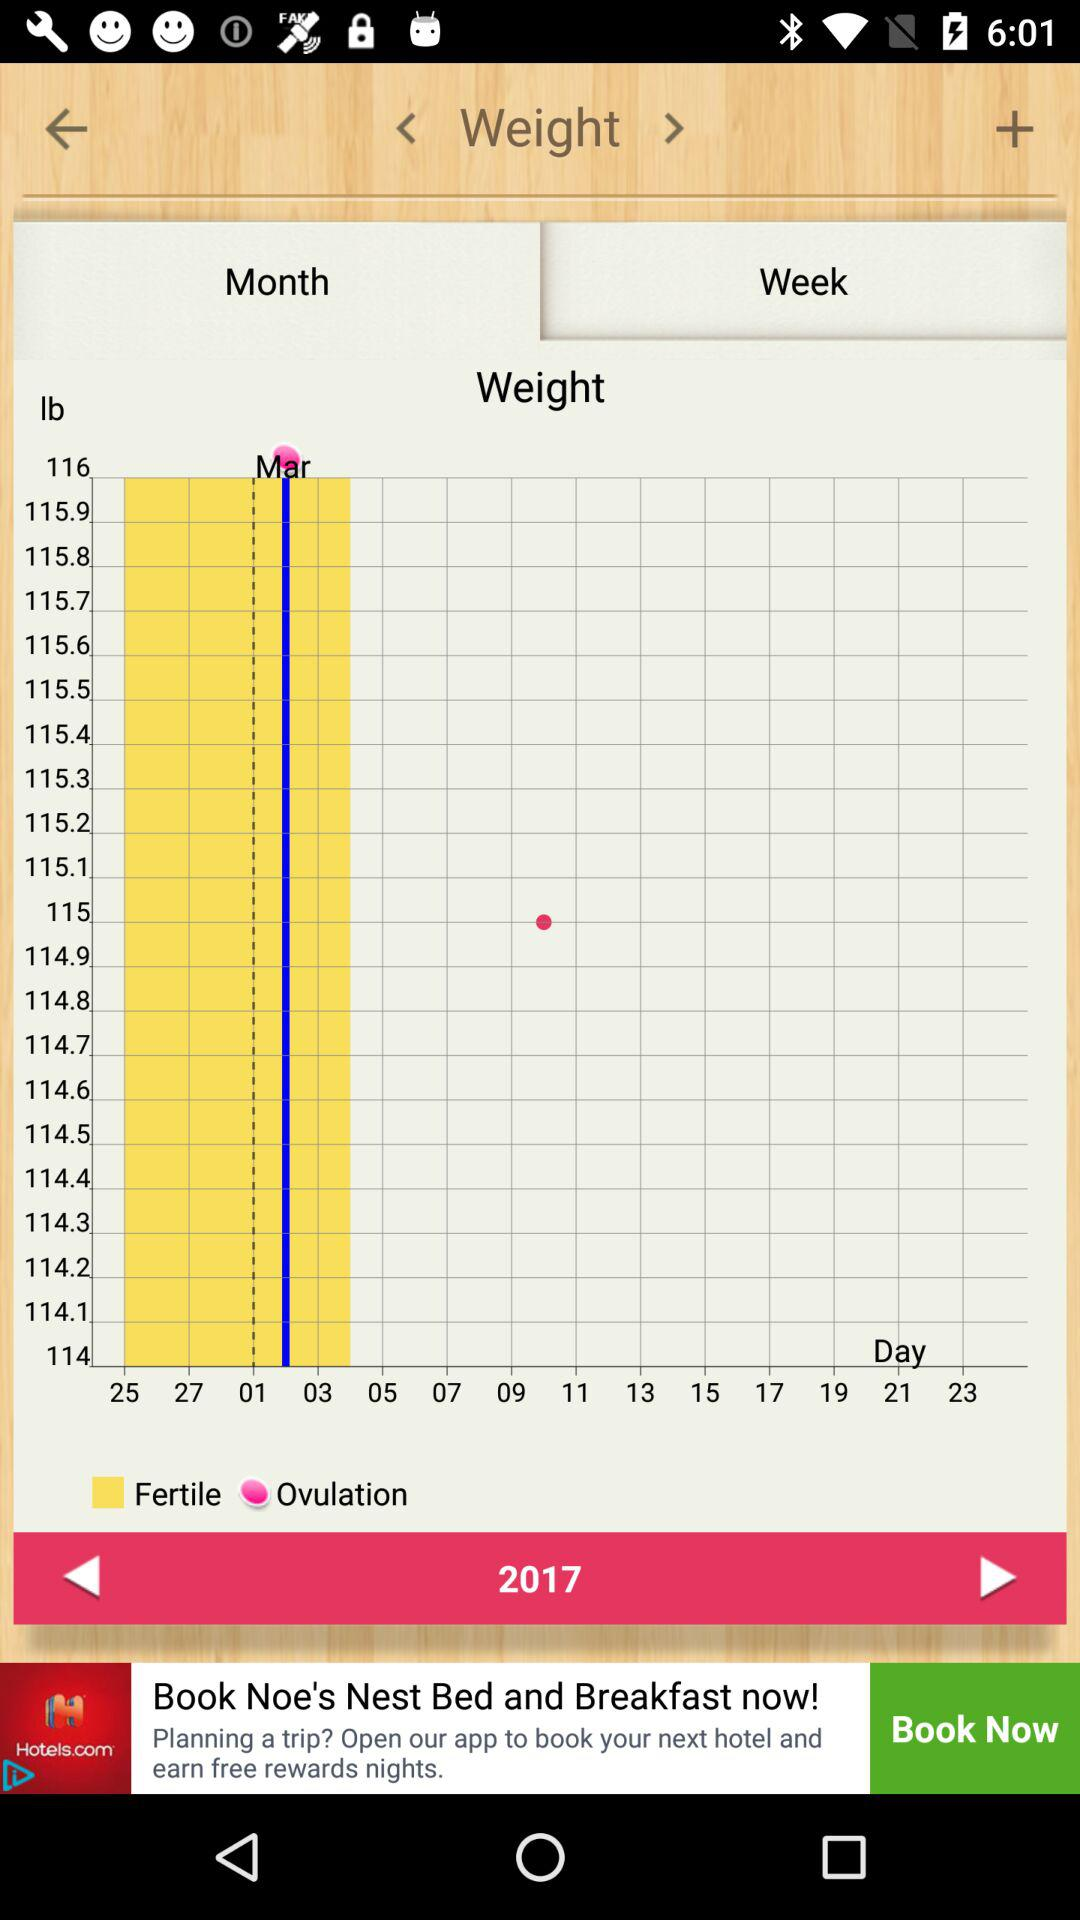Which chart is being shown right now? The chart that is being shown right now is "Weight". 